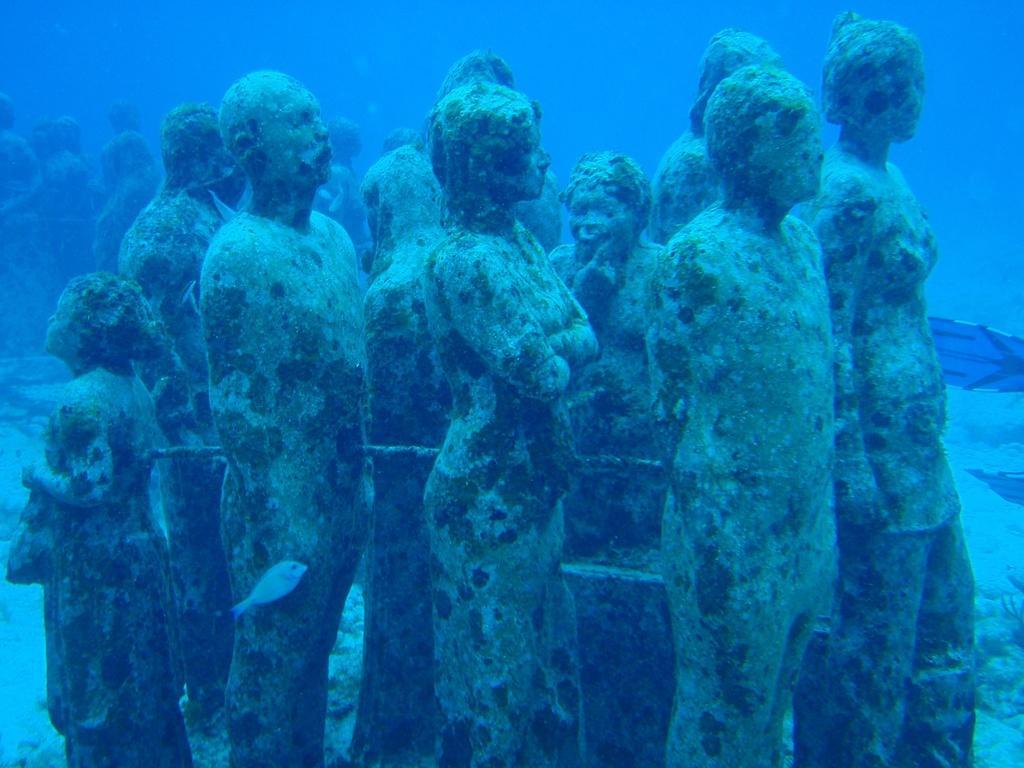Please provide a concise description of this image. In this image we can see the statues under the water and we can see a fish and a few objects. 